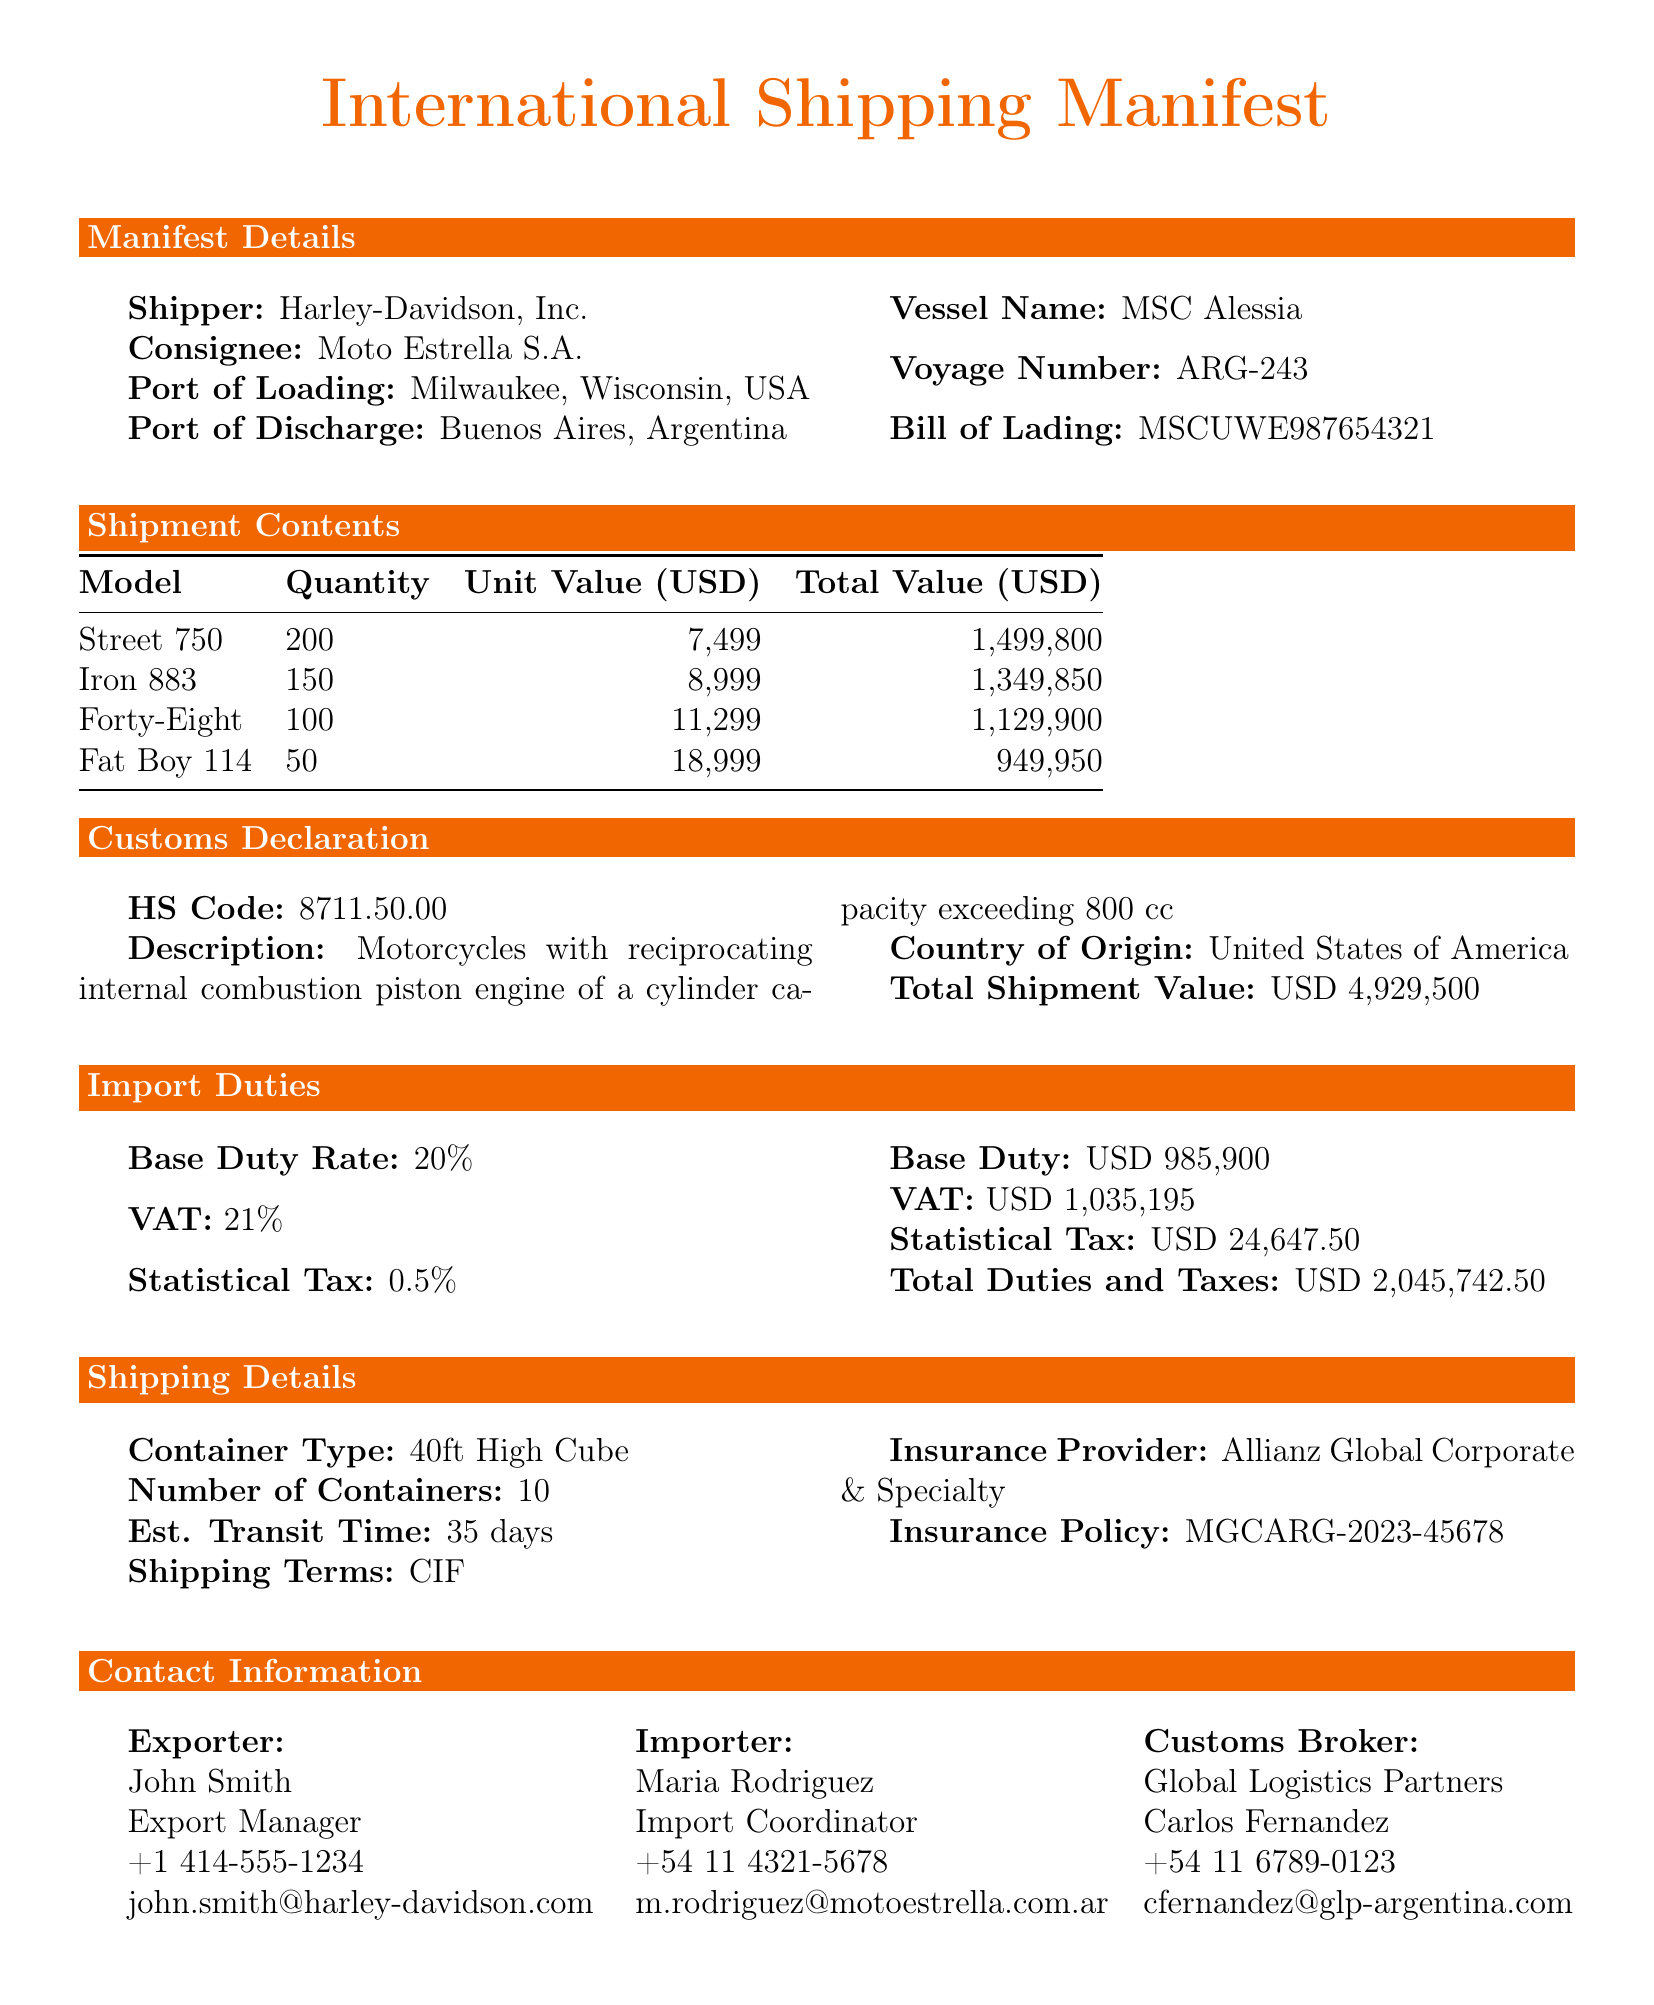What is the total quantity of motorcycles? The total quantity of motorcycles is calculated by adding the quantity of all models listed in the shipment contents. 200 + 150 + 100 + 50 = 500.
Answer: 500 Who is the consignee? The consignee is the company that receives the shipment as listed in the manifest details.
Answer: Moto Estrella S.A What is the base duty rate? The base duty rate is listed under the import duties section in the document.
Answer: 20% What is the total shipment value? The total shipment value is mentioned in the customs declaration section.
Answer: USD 4,929,500 How many containers are used for shipping? The number of containers is listed under the shipping details.
Answer: 10 What is the estimated transit time? The estimated transit time is specified in the shipping details section.
Answer: 35 days What is the VAT rate? The VAT rate is provided in the import duties section of the document.
Answer: 21% What is the insurance policy number? The insurance policy number is mentioned in the shipping details under the insurance provider information.
Answer: MGCARG-2023-45678 Who is the customs broker? The customs broker is listed in the contact information, specific to the customs process for the consignment.
Answer: Global Logistics Partners 